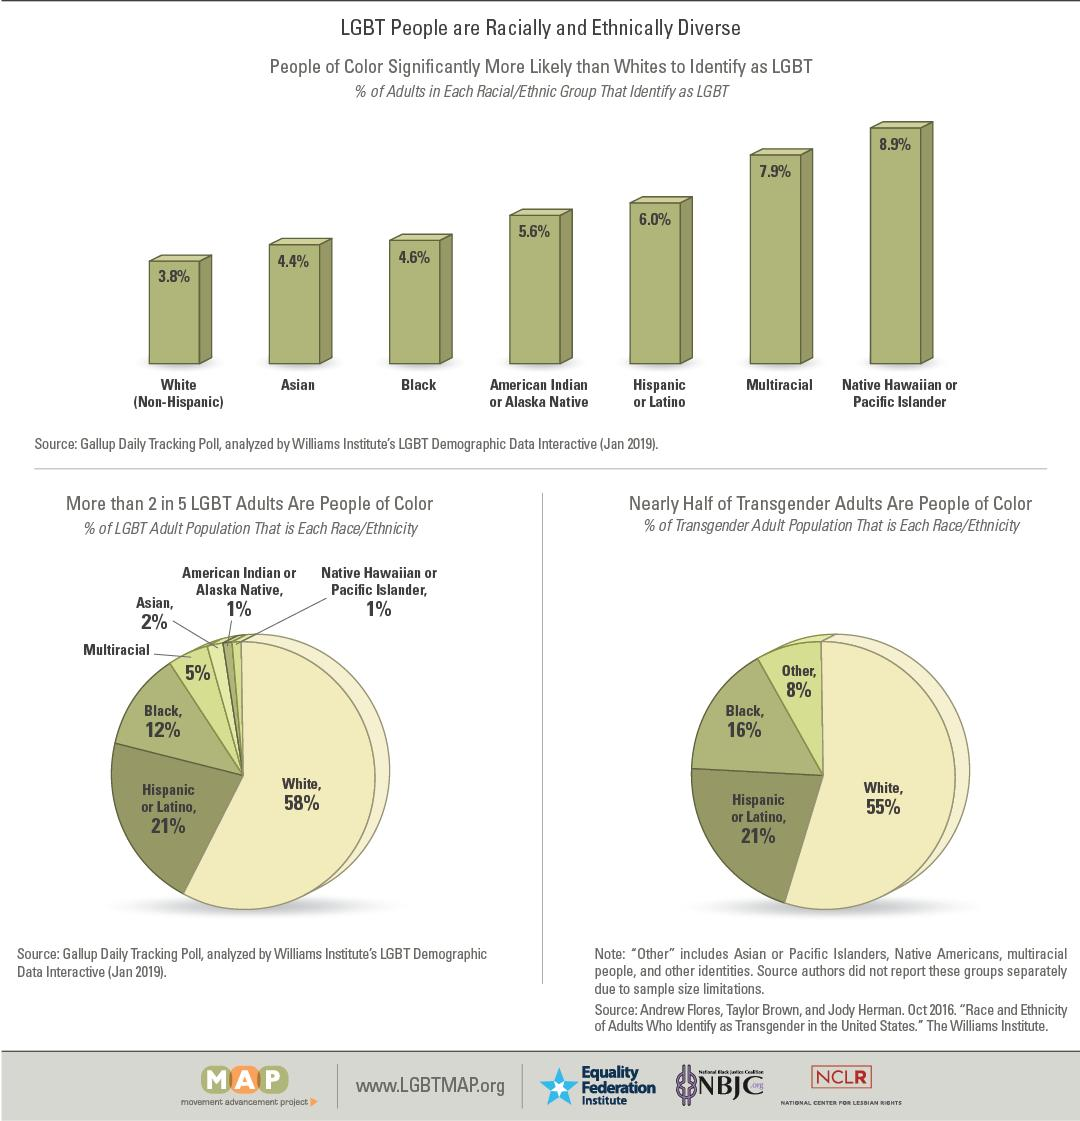Specify some key components in this picture. In October 2016, 37% of Blacks and Hispanics/Latinos combined identified as members of the LGBT community. According to data from January 2019, 42% of the population that identifies as LGBT belongs to racial and ethnic groups other than White. According to a pie chart, approximately 5% of LGBT adults are multiracial. The racial group with the third highest number of people identifying as LGBT is Hispanic or Latino. Asian Americans have the highest number of LGBT individuals, followed by Hispanics/Latinos, Whites, and African Americans, in descending order. American Indian or Alaska Native individuals have the fourth-highest number of LGBT individuals. 